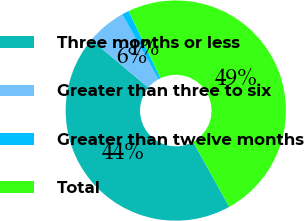Convert chart. <chart><loc_0><loc_0><loc_500><loc_500><pie_chart><fcel>Three months or less<fcel>Greater than three to six<fcel>Greater than twelve months<fcel>Total<nl><fcel>44.17%<fcel>5.83%<fcel>1.04%<fcel>48.96%<nl></chart> 